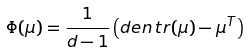Convert formula to latex. <formula><loc_0><loc_0><loc_500><loc_500>\Phi ( \mu ) = \frac { 1 } { d - 1 } \left ( \i d e n \, t r ( \mu ) - \mu ^ { T } \right )</formula> 